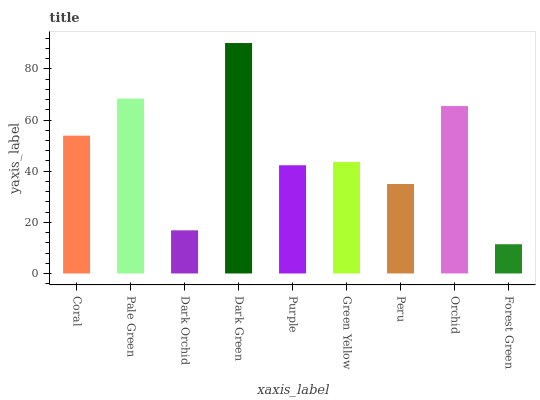Is Forest Green the minimum?
Answer yes or no. Yes. Is Dark Green the maximum?
Answer yes or no. Yes. Is Pale Green the minimum?
Answer yes or no. No. Is Pale Green the maximum?
Answer yes or no. No. Is Pale Green greater than Coral?
Answer yes or no. Yes. Is Coral less than Pale Green?
Answer yes or no. Yes. Is Coral greater than Pale Green?
Answer yes or no. No. Is Pale Green less than Coral?
Answer yes or no. No. Is Green Yellow the high median?
Answer yes or no. Yes. Is Green Yellow the low median?
Answer yes or no. Yes. Is Dark Green the high median?
Answer yes or no. No. Is Orchid the low median?
Answer yes or no. No. 